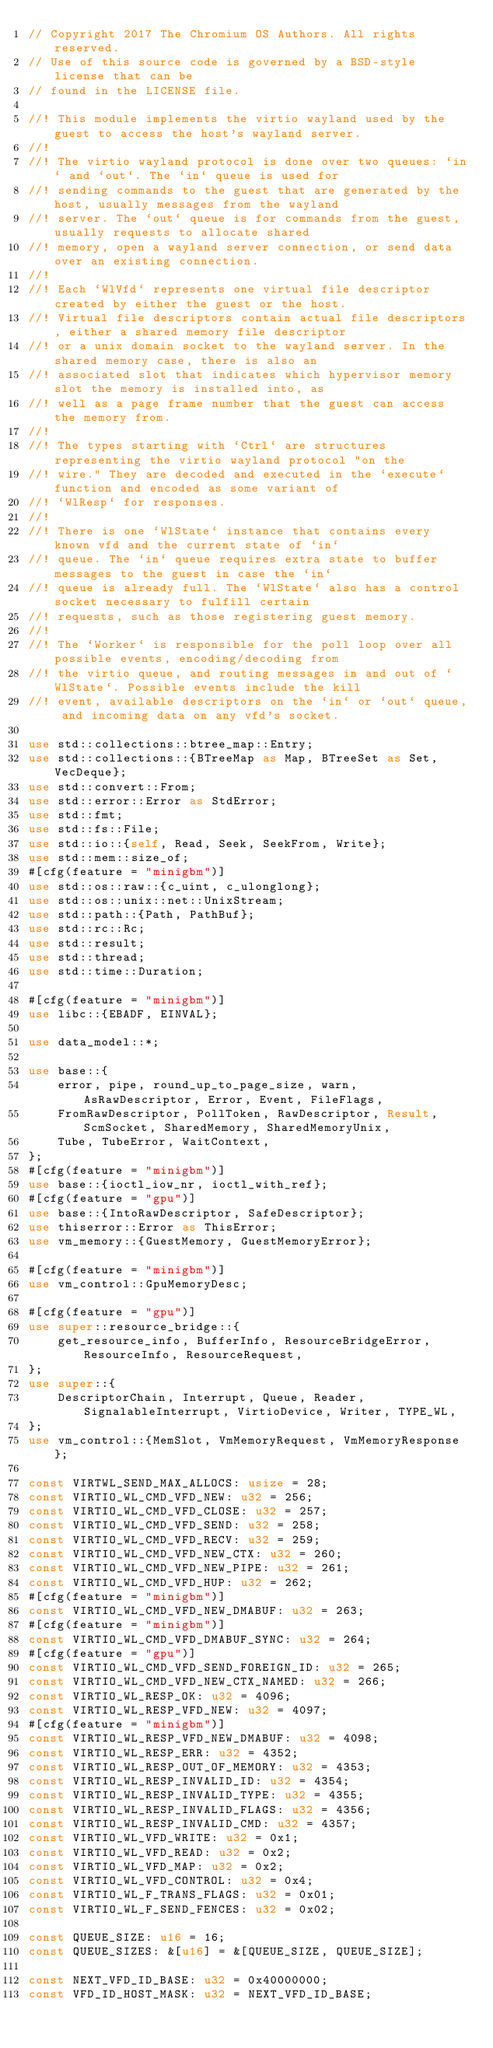<code> <loc_0><loc_0><loc_500><loc_500><_Rust_>// Copyright 2017 The Chromium OS Authors. All rights reserved.
// Use of this source code is governed by a BSD-style license that can be
// found in the LICENSE file.

//! This module implements the virtio wayland used by the guest to access the host's wayland server.
//!
//! The virtio wayland protocol is done over two queues: `in` and `out`. The `in` queue is used for
//! sending commands to the guest that are generated by the host, usually messages from the wayland
//! server. The `out` queue is for commands from the guest, usually requests to allocate shared
//! memory, open a wayland server connection, or send data over an existing connection.
//!
//! Each `WlVfd` represents one virtual file descriptor created by either the guest or the host.
//! Virtual file descriptors contain actual file descriptors, either a shared memory file descriptor
//! or a unix domain socket to the wayland server. In the shared memory case, there is also an
//! associated slot that indicates which hypervisor memory slot the memory is installed into, as
//! well as a page frame number that the guest can access the memory from.
//!
//! The types starting with `Ctrl` are structures representing the virtio wayland protocol "on the
//! wire." They are decoded and executed in the `execute` function and encoded as some variant of
//! `WlResp` for responses.
//!
//! There is one `WlState` instance that contains every known vfd and the current state of `in`
//! queue. The `in` queue requires extra state to buffer messages to the guest in case the `in`
//! queue is already full. The `WlState` also has a control socket necessary to fulfill certain
//! requests, such as those registering guest memory.
//!
//! The `Worker` is responsible for the poll loop over all possible events, encoding/decoding from
//! the virtio queue, and routing messages in and out of `WlState`. Possible events include the kill
//! event, available descriptors on the `in` or `out` queue, and incoming data on any vfd's socket.

use std::collections::btree_map::Entry;
use std::collections::{BTreeMap as Map, BTreeSet as Set, VecDeque};
use std::convert::From;
use std::error::Error as StdError;
use std::fmt;
use std::fs::File;
use std::io::{self, Read, Seek, SeekFrom, Write};
use std::mem::size_of;
#[cfg(feature = "minigbm")]
use std::os::raw::{c_uint, c_ulonglong};
use std::os::unix::net::UnixStream;
use std::path::{Path, PathBuf};
use std::rc::Rc;
use std::result;
use std::thread;
use std::time::Duration;

#[cfg(feature = "minigbm")]
use libc::{EBADF, EINVAL};

use data_model::*;

use base::{
    error, pipe, round_up_to_page_size, warn, AsRawDescriptor, Error, Event, FileFlags,
    FromRawDescriptor, PollToken, RawDescriptor, Result, ScmSocket, SharedMemory, SharedMemoryUnix,
    Tube, TubeError, WaitContext,
};
#[cfg(feature = "minigbm")]
use base::{ioctl_iow_nr, ioctl_with_ref};
#[cfg(feature = "gpu")]
use base::{IntoRawDescriptor, SafeDescriptor};
use thiserror::Error as ThisError;
use vm_memory::{GuestMemory, GuestMemoryError};

#[cfg(feature = "minigbm")]
use vm_control::GpuMemoryDesc;

#[cfg(feature = "gpu")]
use super::resource_bridge::{
    get_resource_info, BufferInfo, ResourceBridgeError, ResourceInfo, ResourceRequest,
};
use super::{
    DescriptorChain, Interrupt, Queue, Reader, SignalableInterrupt, VirtioDevice, Writer, TYPE_WL,
};
use vm_control::{MemSlot, VmMemoryRequest, VmMemoryResponse};

const VIRTWL_SEND_MAX_ALLOCS: usize = 28;
const VIRTIO_WL_CMD_VFD_NEW: u32 = 256;
const VIRTIO_WL_CMD_VFD_CLOSE: u32 = 257;
const VIRTIO_WL_CMD_VFD_SEND: u32 = 258;
const VIRTIO_WL_CMD_VFD_RECV: u32 = 259;
const VIRTIO_WL_CMD_VFD_NEW_CTX: u32 = 260;
const VIRTIO_WL_CMD_VFD_NEW_PIPE: u32 = 261;
const VIRTIO_WL_CMD_VFD_HUP: u32 = 262;
#[cfg(feature = "minigbm")]
const VIRTIO_WL_CMD_VFD_NEW_DMABUF: u32 = 263;
#[cfg(feature = "minigbm")]
const VIRTIO_WL_CMD_VFD_DMABUF_SYNC: u32 = 264;
#[cfg(feature = "gpu")]
const VIRTIO_WL_CMD_VFD_SEND_FOREIGN_ID: u32 = 265;
const VIRTIO_WL_CMD_VFD_NEW_CTX_NAMED: u32 = 266;
const VIRTIO_WL_RESP_OK: u32 = 4096;
const VIRTIO_WL_RESP_VFD_NEW: u32 = 4097;
#[cfg(feature = "minigbm")]
const VIRTIO_WL_RESP_VFD_NEW_DMABUF: u32 = 4098;
const VIRTIO_WL_RESP_ERR: u32 = 4352;
const VIRTIO_WL_RESP_OUT_OF_MEMORY: u32 = 4353;
const VIRTIO_WL_RESP_INVALID_ID: u32 = 4354;
const VIRTIO_WL_RESP_INVALID_TYPE: u32 = 4355;
const VIRTIO_WL_RESP_INVALID_FLAGS: u32 = 4356;
const VIRTIO_WL_RESP_INVALID_CMD: u32 = 4357;
const VIRTIO_WL_VFD_WRITE: u32 = 0x1;
const VIRTIO_WL_VFD_READ: u32 = 0x2;
const VIRTIO_WL_VFD_MAP: u32 = 0x2;
const VIRTIO_WL_VFD_CONTROL: u32 = 0x4;
const VIRTIO_WL_F_TRANS_FLAGS: u32 = 0x01;
const VIRTIO_WL_F_SEND_FENCES: u32 = 0x02;

const QUEUE_SIZE: u16 = 16;
const QUEUE_SIZES: &[u16] = &[QUEUE_SIZE, QUEUE_SIZE];

const NEXT_VFD_ID_BASE: u32 = 0x40000000;
const VFD_ID_HOST_MASK: u32 = NEXT_VFD_ID_BASE;</code> 